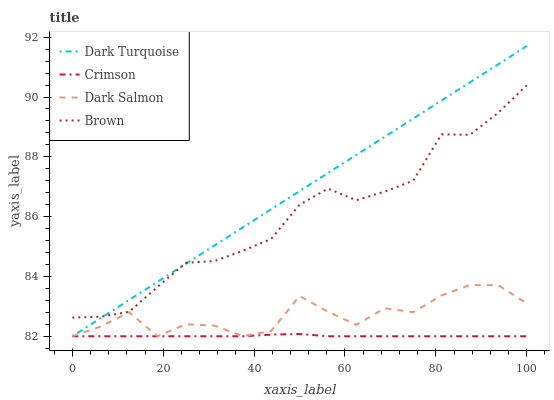Does Dark Salmon have the minimum area under the curve?
Answer yes or no. No. Does Dark Salmon have the maximum area under the curve?
Answer yes or no. No. Is Dark Salmon the smoothest?
Answer yes or no. No. Is Dark Turquoise the roughest?
Answer yes or no. No. Does Brown have the lowest value?
Answer yes or no. No. Does Dark Salmon have the highest value?
Answer yes or no. No. Is Dark Salmon less than Brown?
Answer yes or no. Yes. Is Brown greater than Dark Salmon?
Answer yes or no. Yes. Does Dark Salmon intersect Brown?
Answer yes or no. No. 